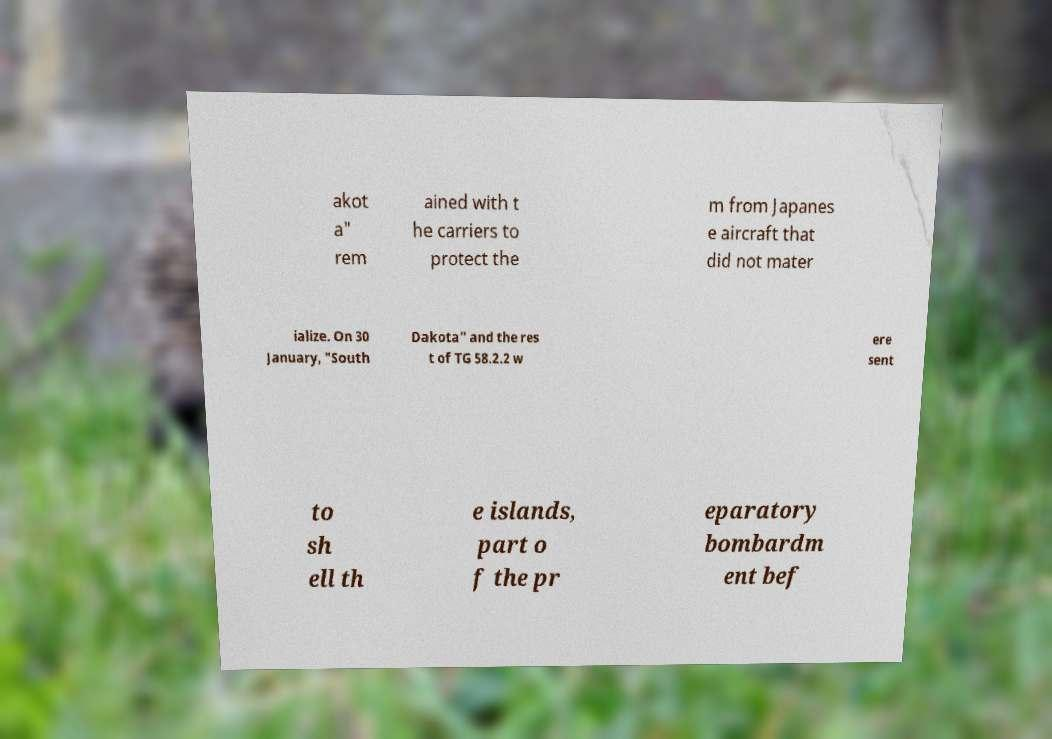Could you assist in decoding the text presented in this image and type it out clearly? akot a" rem ained with t he carriers to protect the m from Japanes e aircraft that did not mater ialize. On 30 January, "South Dakota" and the res t of TG 58.2.2 w ere sent to sh ell th e islands, part o f the pr eparatory bombardm ent bef 